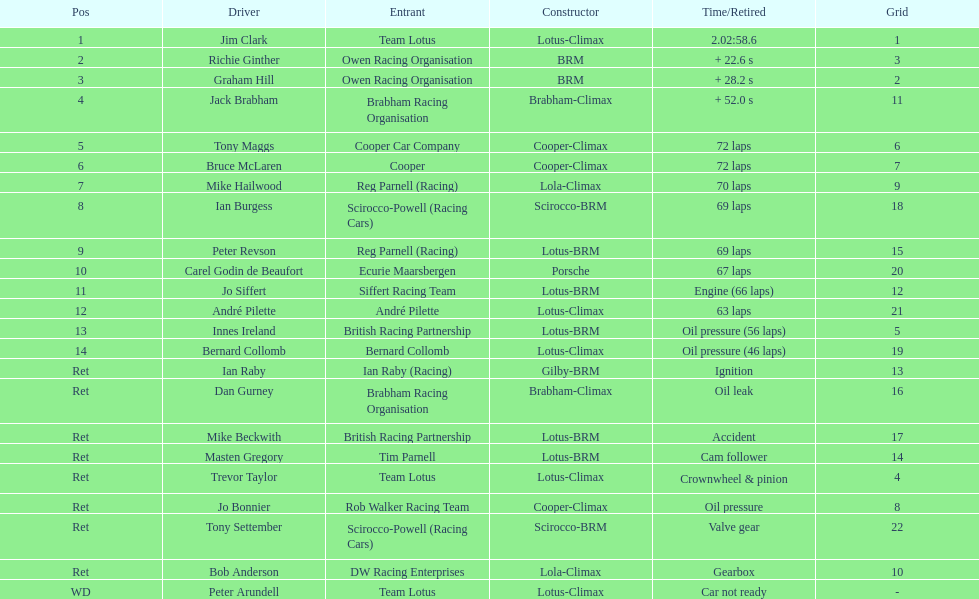Which driver did not have his/her car ready? Peter Arundell. 